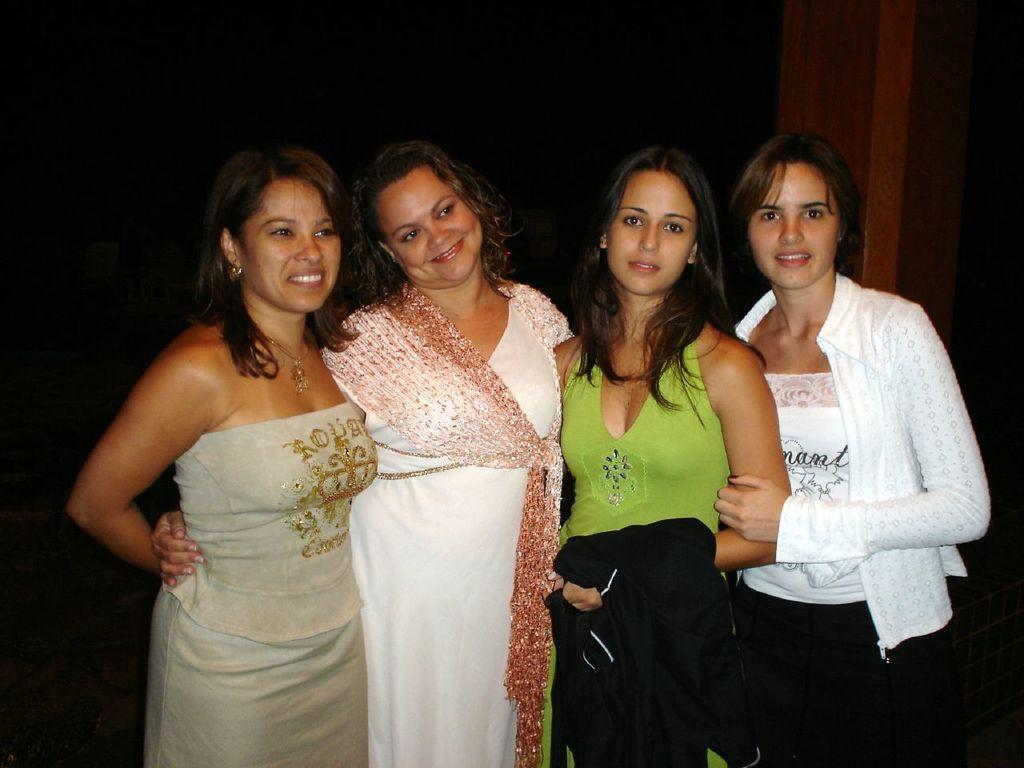In one or two sentences, can you explain what this image depicts? In this image we can see few people standing and posing for a photo and in the background the image is dark. 